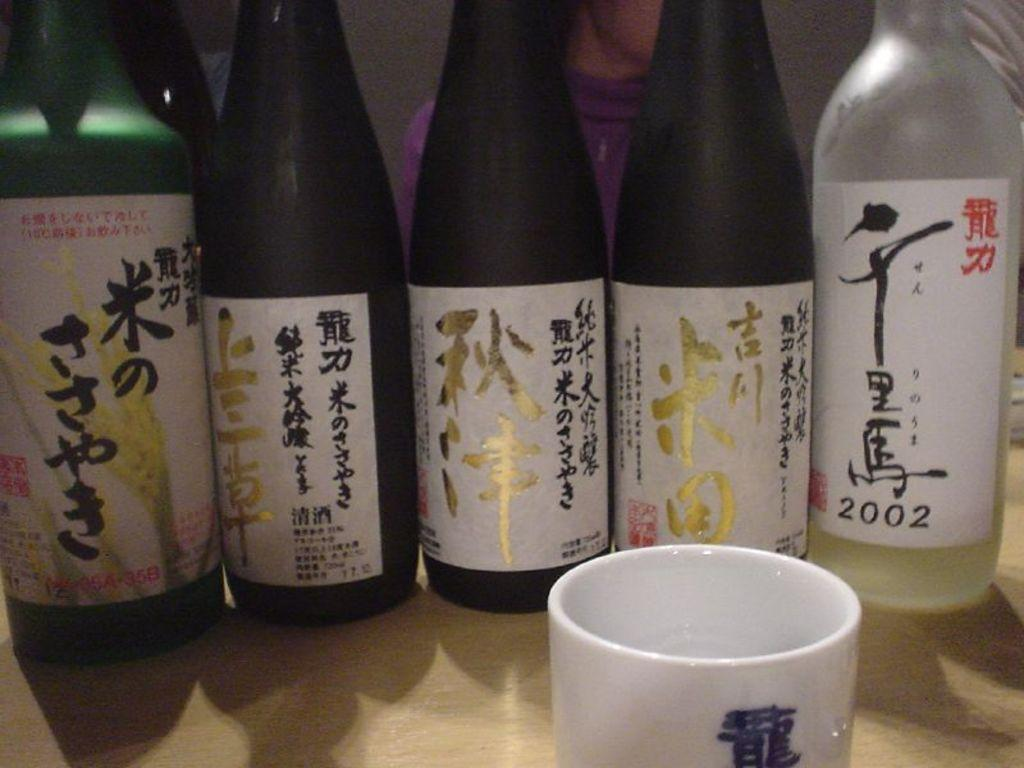<image>
Offer a succinct explanation of the picture presented. Different types of beer bottles with one of the beer bottles that says 2002. 